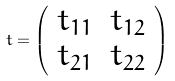Convert formula to latex. <formula><loc_0><loc_0><loc_500><loc_500>t = \left ( \begin{array} { c c } t _ { 1 1 } & t _ { 1 2 } \\ t _ { 2 1 } & t _ { 2 2 } \end{array} \right )</formula> 